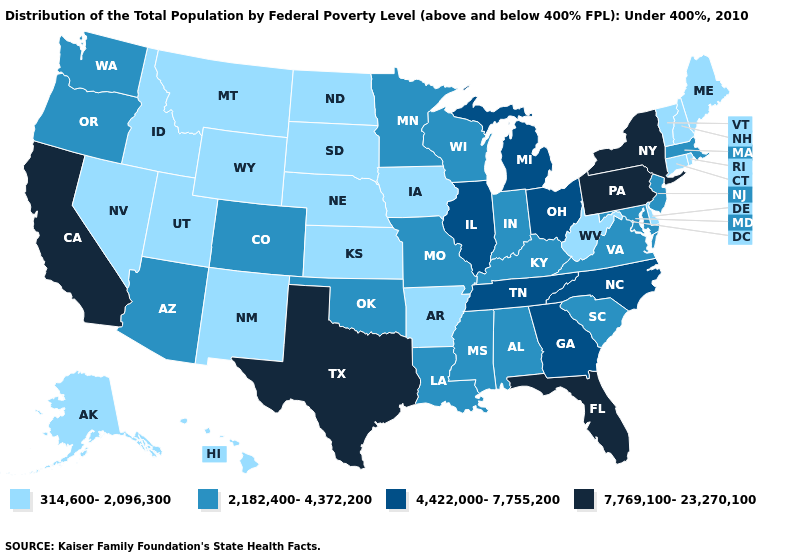Name the states that have a value in the range 314,600-2,096,300?
Give a very brief answer. Alaska, Arkansas, Connecticut, Delaware, Hawaii, Idaho, Iowa, Kansas, Maine, Montana, Nebraska, Nevada, New Hampshire, New Mexico, North Dakota, Rhode Island, South Dakota, Utah, Vermont, West Virginia, Wyoming. What is the value of Maine?
Give a very brief answer. 314,600-2,096,300. Name the states that have a value in the range 4,422,000-7,755,200?
Keep it brief. Georgia, Illinois, Michigan, North Carolina, Ohio, Tennessee. What is the lowest value in the USA?
Keep it brief. 314,600-2,096,300. Name the states that have a value in the range 4,422,000-7,755,200?
Be succinct. Georgia, Illinois, Michigan, North Carolina, Ohio, Tennessee. What is the value of New York?
Give a very brief answer. 7,769,100-23,270,100. What is the lowest value in the USA?
Keep it brief. 314,600-2,096,300. What is the highest value in the USA?
Short answer required. 7,769,100-23,270,100. Is the legend a continuous bar?
Be succinct. No. What is the highest value in states that border Michigan?
Concise answer only. 4,422,000-7,755,200. Among the states that border Connecticut , does New York have the highest value?
Quick response, please. Yes. Which states have the lowest value in the USA?
Concise answer only. Alaska, Arkansas, Connecticut, Delaware, Hawaii, Idaho, Iowa, Kansas, Maine, Montana, Nebraska, Nevada, New Hampshire, New Mexico, North Dakota, Rhode Island, South Dakota, Utah, Vermont, West Virginia, Wyoming. What is the highest value in the USA?
Keep it brief. 7,769,100-23,270,100. Among the states that border Missouri , does Kentucky have the lowest value?
Keep it brief. No. Which states hav the highest value in the West?
Quick response, please. California. 